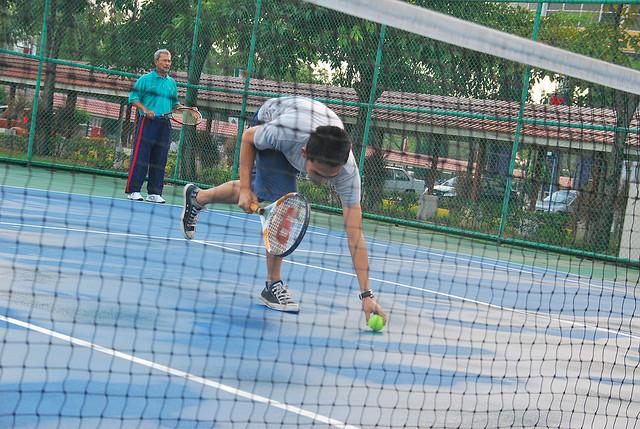Which company makes the green object here? Please explain your reasoning. wilson. Wilson is known for making tennis balls. 